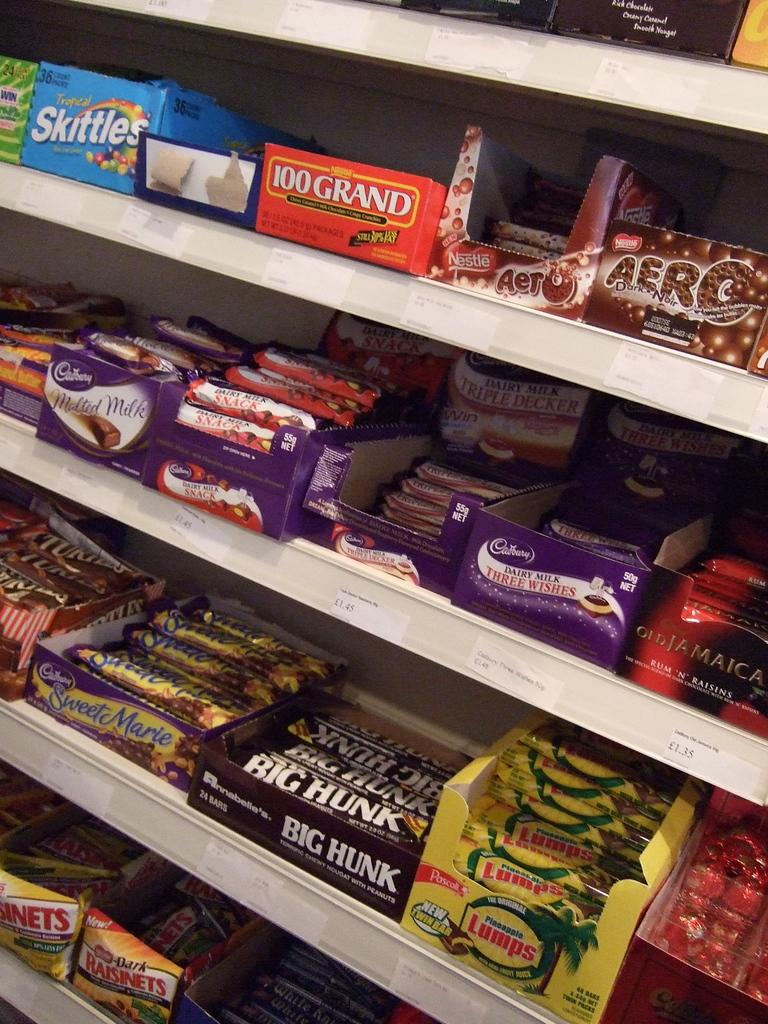<image>
Present a compact description of the photo's key features. Multiple shelves that have different candy bars on there, like skittles, 100 grand, etc 